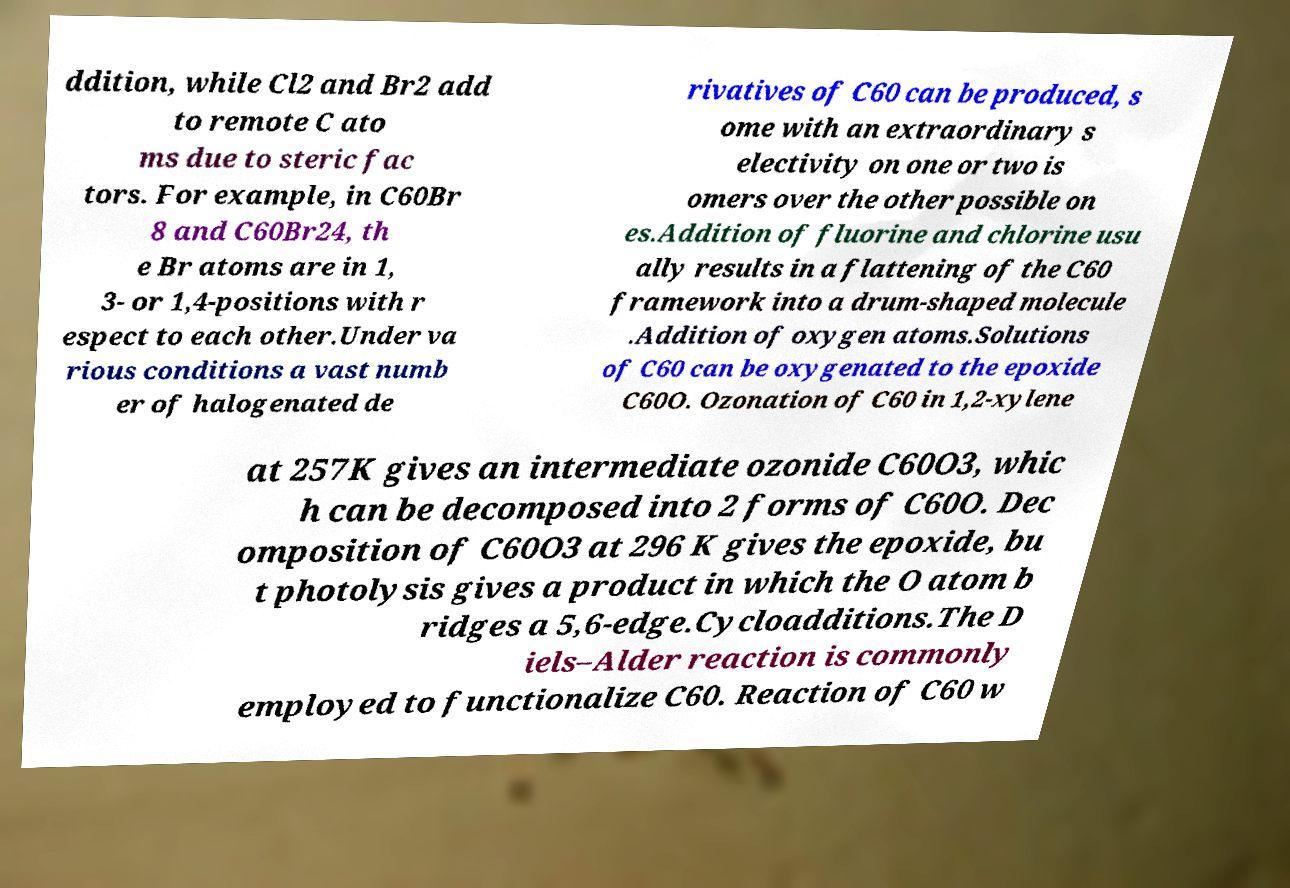Can you read and provide the text displayed in the image?This photo seems to have some interesting text. Can you extract and type it out for me? ddition, while Cl2 and Br2 add to remote C ato ms due to steric fac tors. For example, in C60Br 8 and C60Br24, th e Br atoms are in 1, 3- or 1,4-positions with r espect to each other.Under va rious conditions a vast numb er of halogenated de rivatives of C60 can be produced, s ome with an extraordinary s electivity on one or two is omers over the other possible on es.Addition of fluorine and chlorine usu ally results in a flattening of the C60 framework into a drum-shaped molecule .Addition of oxygen atoms.Solutions of C60 can be oxygenated to the epoxide C60O. Ozonation of C60 in 1,2-xylene at 257K gives an intermediate ozonide C60O3, whic h can be decomposed into 2 forms of C60O. Dec omposition of C60O3 at 296 K gives the epoxide, bu t photolysis gives a product in which the O atom b ridges a 5,6-edge.Cycloadditions.The D iels–Alder reaction is commonly employed to functionalize C60. Reaction of C60 w 